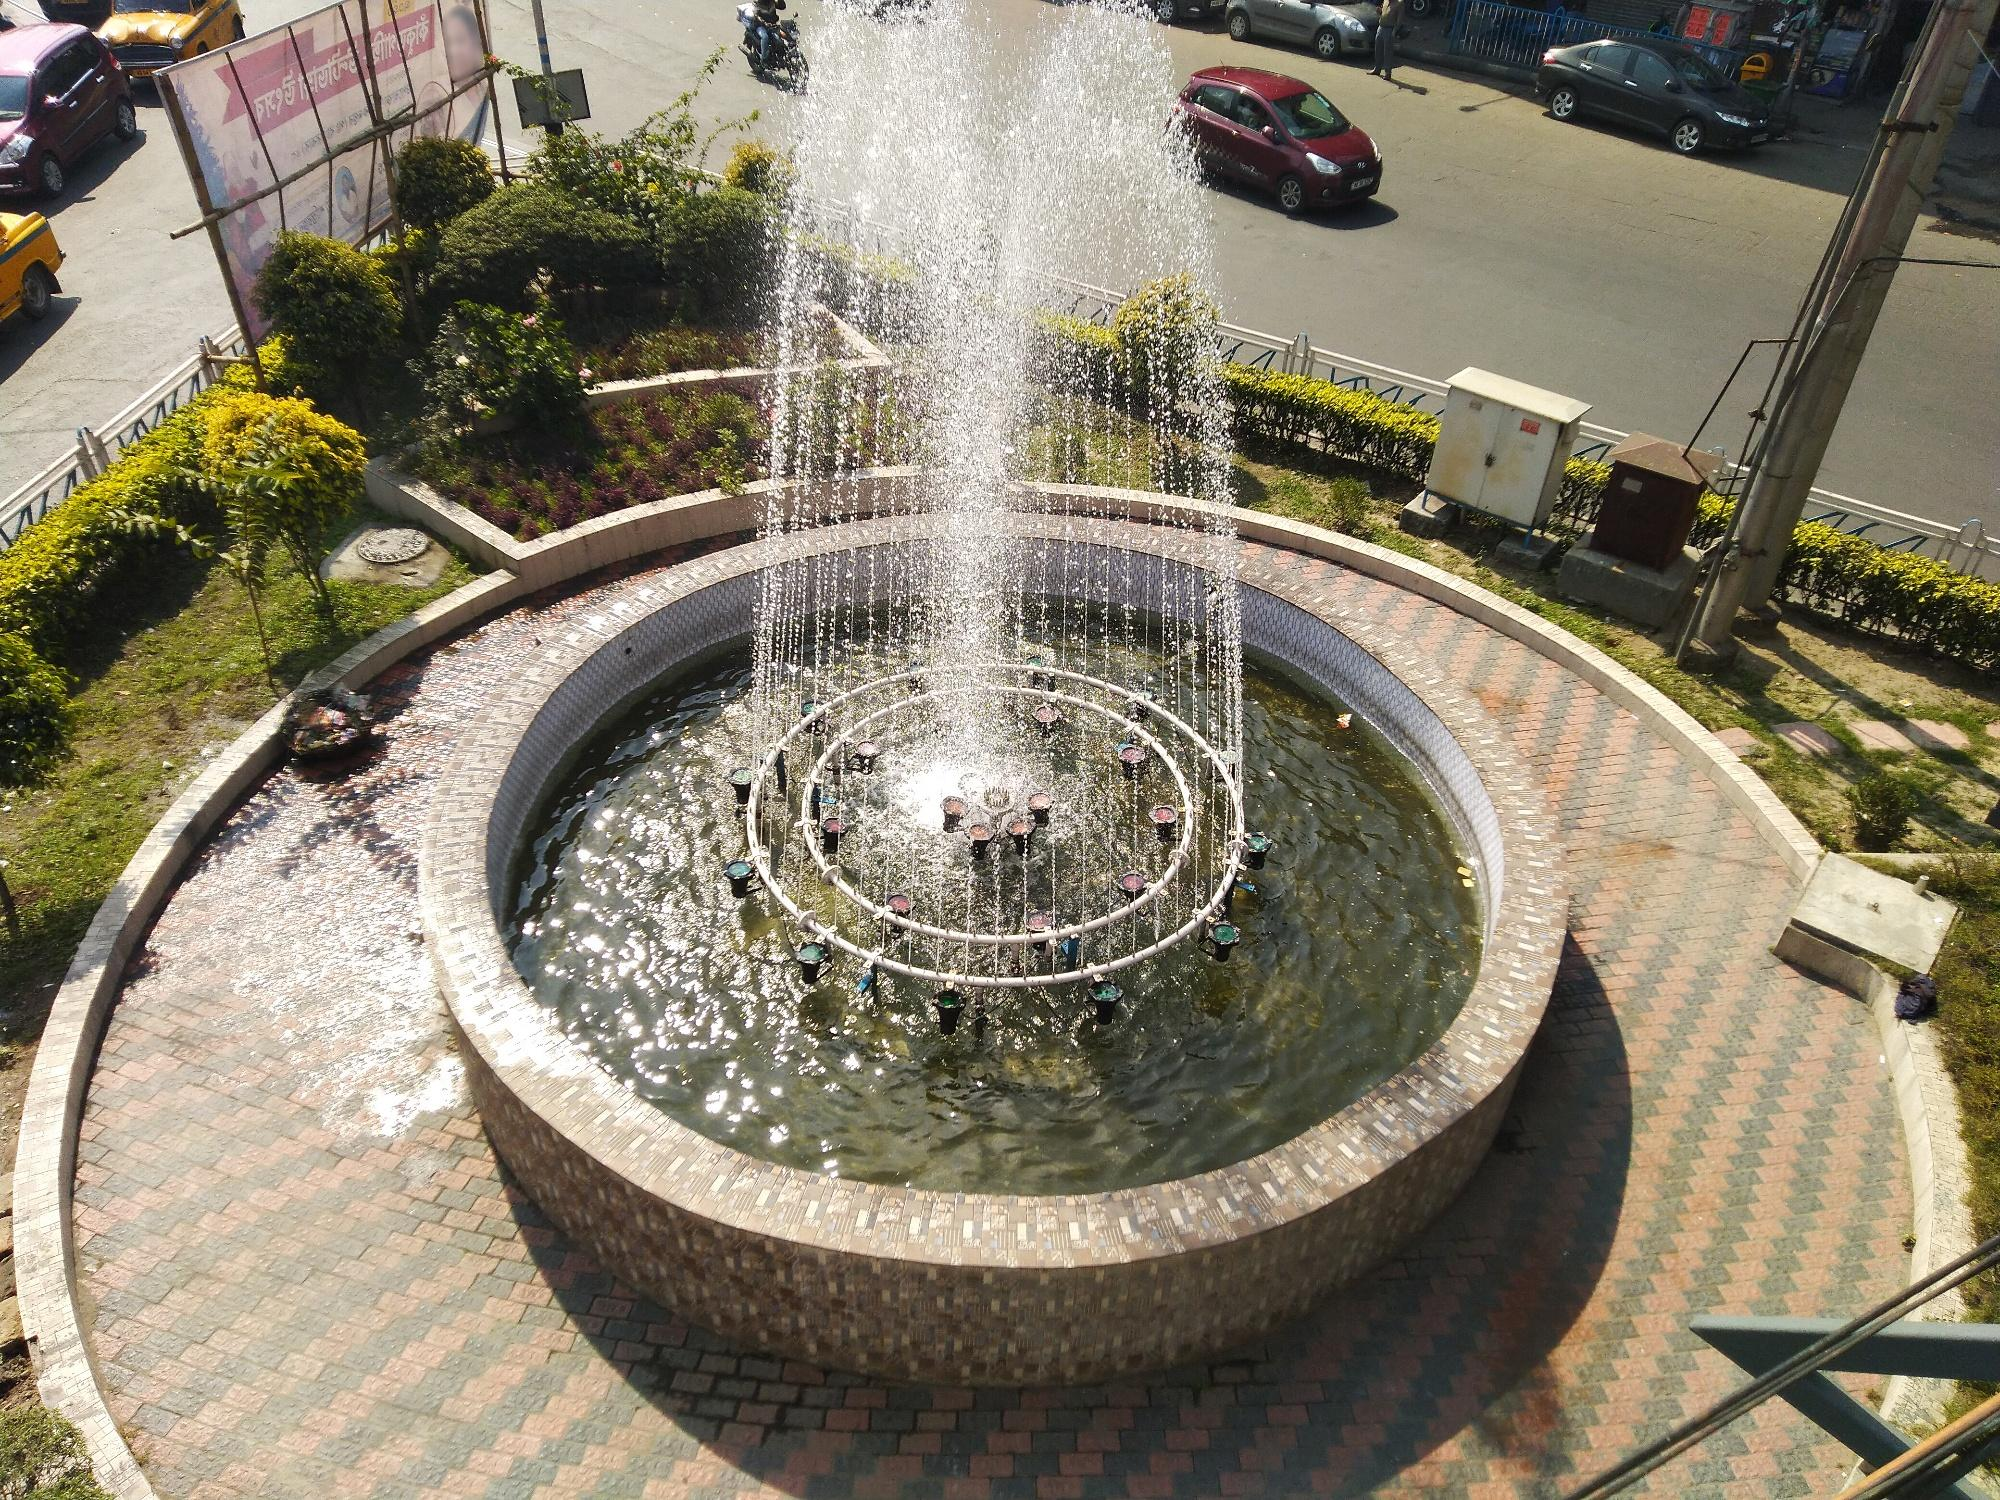What practical steps could local authorities take to improve this space even further? Local authorities could enhance this space by installing benches around the fountain, providing additional seating areas for visitors. Introducing interactive water features could make the spot more engaging for children. Adding more lighting for safety and ambiance, especially at night, would enrich the overall experience.

Regular maintenance schedules should be established to ensure cleanliness and functionality. Incorporating sustainable practices, such as rainwater harvesting systems to supply the fountain, would be environmentally friendly. Authorities could also use the space for community events, turning it into a focal point for social activities. 